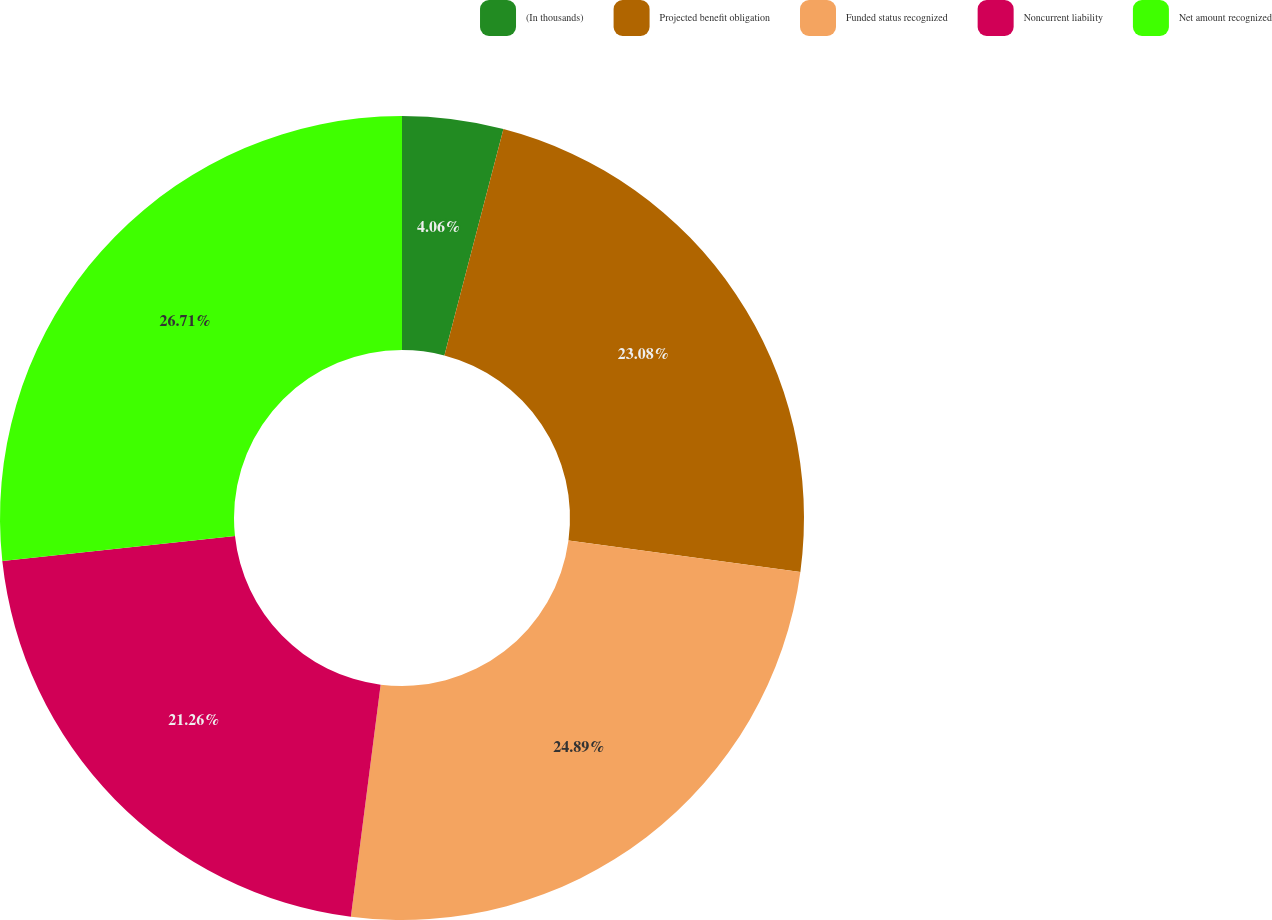<chart> <loc_0><loc_0><loc_500><loc_500><pie_chart><fcel>(In thousands)<fcel>Projected benefit obligation<fcel>Funded status recognized<fcel>Noncurrent liability<fcel>Net amount recognized<nl><fcel>4.06%<fcel>23.08%<fcel>24.89%<fcel>21.26%<fcel>26.71%<nl></chart> 